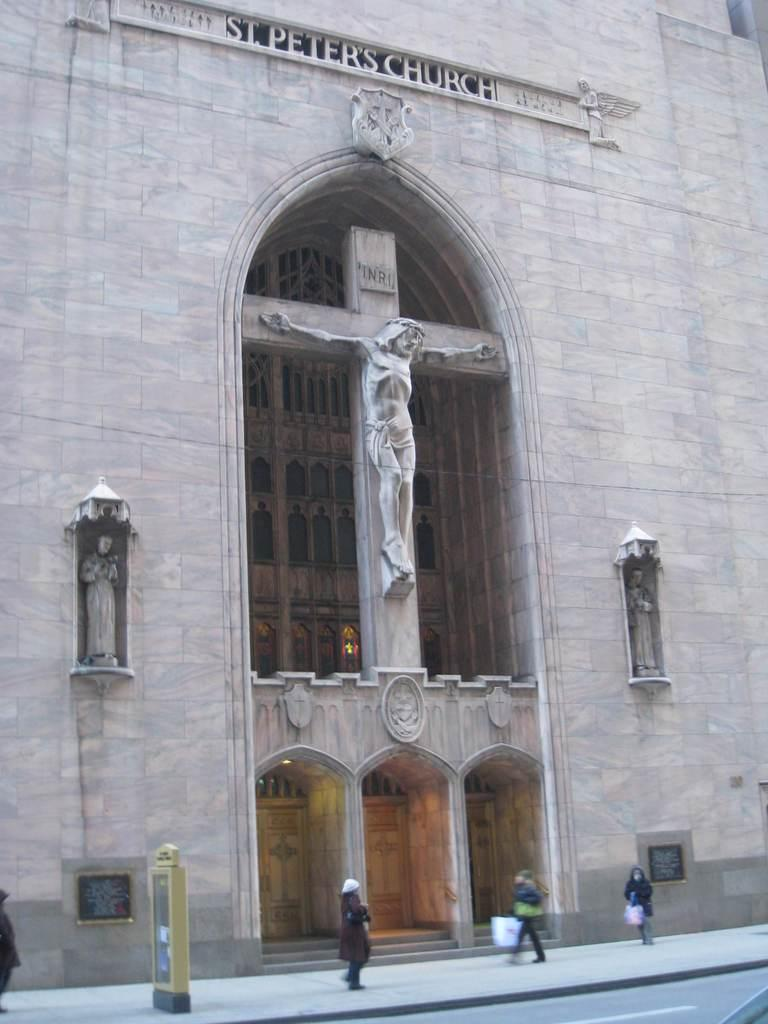What can be seen in the image involving people? There are people standing in the image. What objects are present in the image that are not people? There are boards and sculptures in the image. What can be seen in the background of the image? There is a building in the background of the image. What type of stocking is being used by the people in the image? There is no mention of stockings in the image, so it cannot be determined if any are being used. 